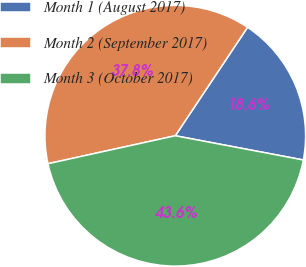Convert chart. <chart><loc_0><loc_0><loc_500><loc_500><pie_chart><fcel>Month 1 (August 2017)<fcel>Month 2 (September 2017)<fcel>Month 3 (October 2017)<nl><fcel>18.62%<fcel>37.8%<fcel>43.58%<nl></chart> 